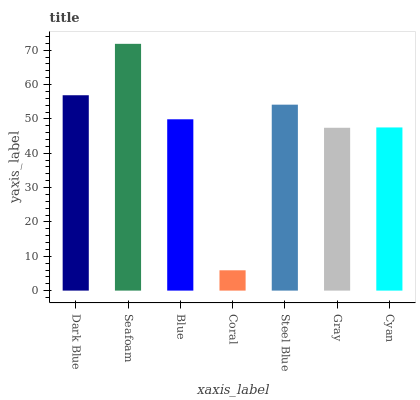Is Coral the minimum?
Answer yes or no. Yes. Is Seafoam the maximum?
Answer yes or no. Yes. Is Blue the minimum?
Answer yes or no. No. Is Blue the maximum?
Answer yes or no. No. Is Seafoam greater than Blue?
Answer yes or no. Yes. Is Blue less than Seafoam?
Answer yes or no. Yes. Is Blue greater than Seafoam?
Answer yes or no. No. Is Seafoam less than Blue?
Answer yes or no. No. Is Blue the high median?
Answer yes or no. Yes. Is Blue the low median?
Answer yes or no. Yes. Is Cyan the high median?
Answer yes or no. No. Is Seafoam the low median?
Answer yes or no. No. 